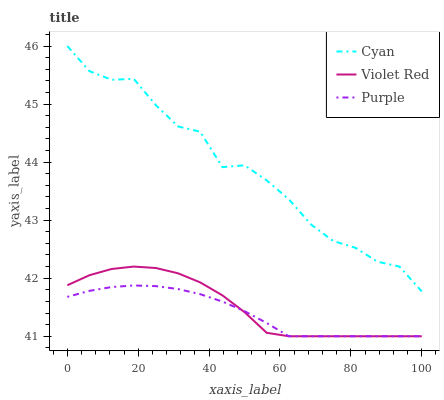Does Purple have the minimum area under the curve?
Answer yes or no. Yes. Does Cyan have the maximum area under the curve?
Answer yes or no. Yes. Does Violet Red have the minimum area under the curve?
Answer yes or no. No. Does Violet Red have the maximum area under the curve?
Answer yes or no. No. Is Purple the smoothest?
Answer yes or no. Yes. Is Cyan the roughest?
Answer yes or no. Yes. Is Violet Red the smoothest?
Answer yes or no. No. Is Violet Red the roughest?
Answer yes or no. No. Does Purple have the lowest value?
Answer yes or no. Yes. Does Cyan have the lowest value?
Answer yes or no. No. Does Cyan have the highest value?
Answer yes or no. Yes. Does Violet Red have the highest value?
Answer yes or no. No. Is Violet Red less than Cyan?
Answer yes or no. Yes. Is Cyan greater than Violet Red?
Answer yes or no. Yes. Does Violet Red intersect Purple?
Answer yes or no. Yes. Is Violet Red less than Purple?
Answer yes or no. No. Is Violet Red greater than Purple?
Answer yes or no. No. Does Violet Red intersect Cyan?
Answer yes or no. No. 